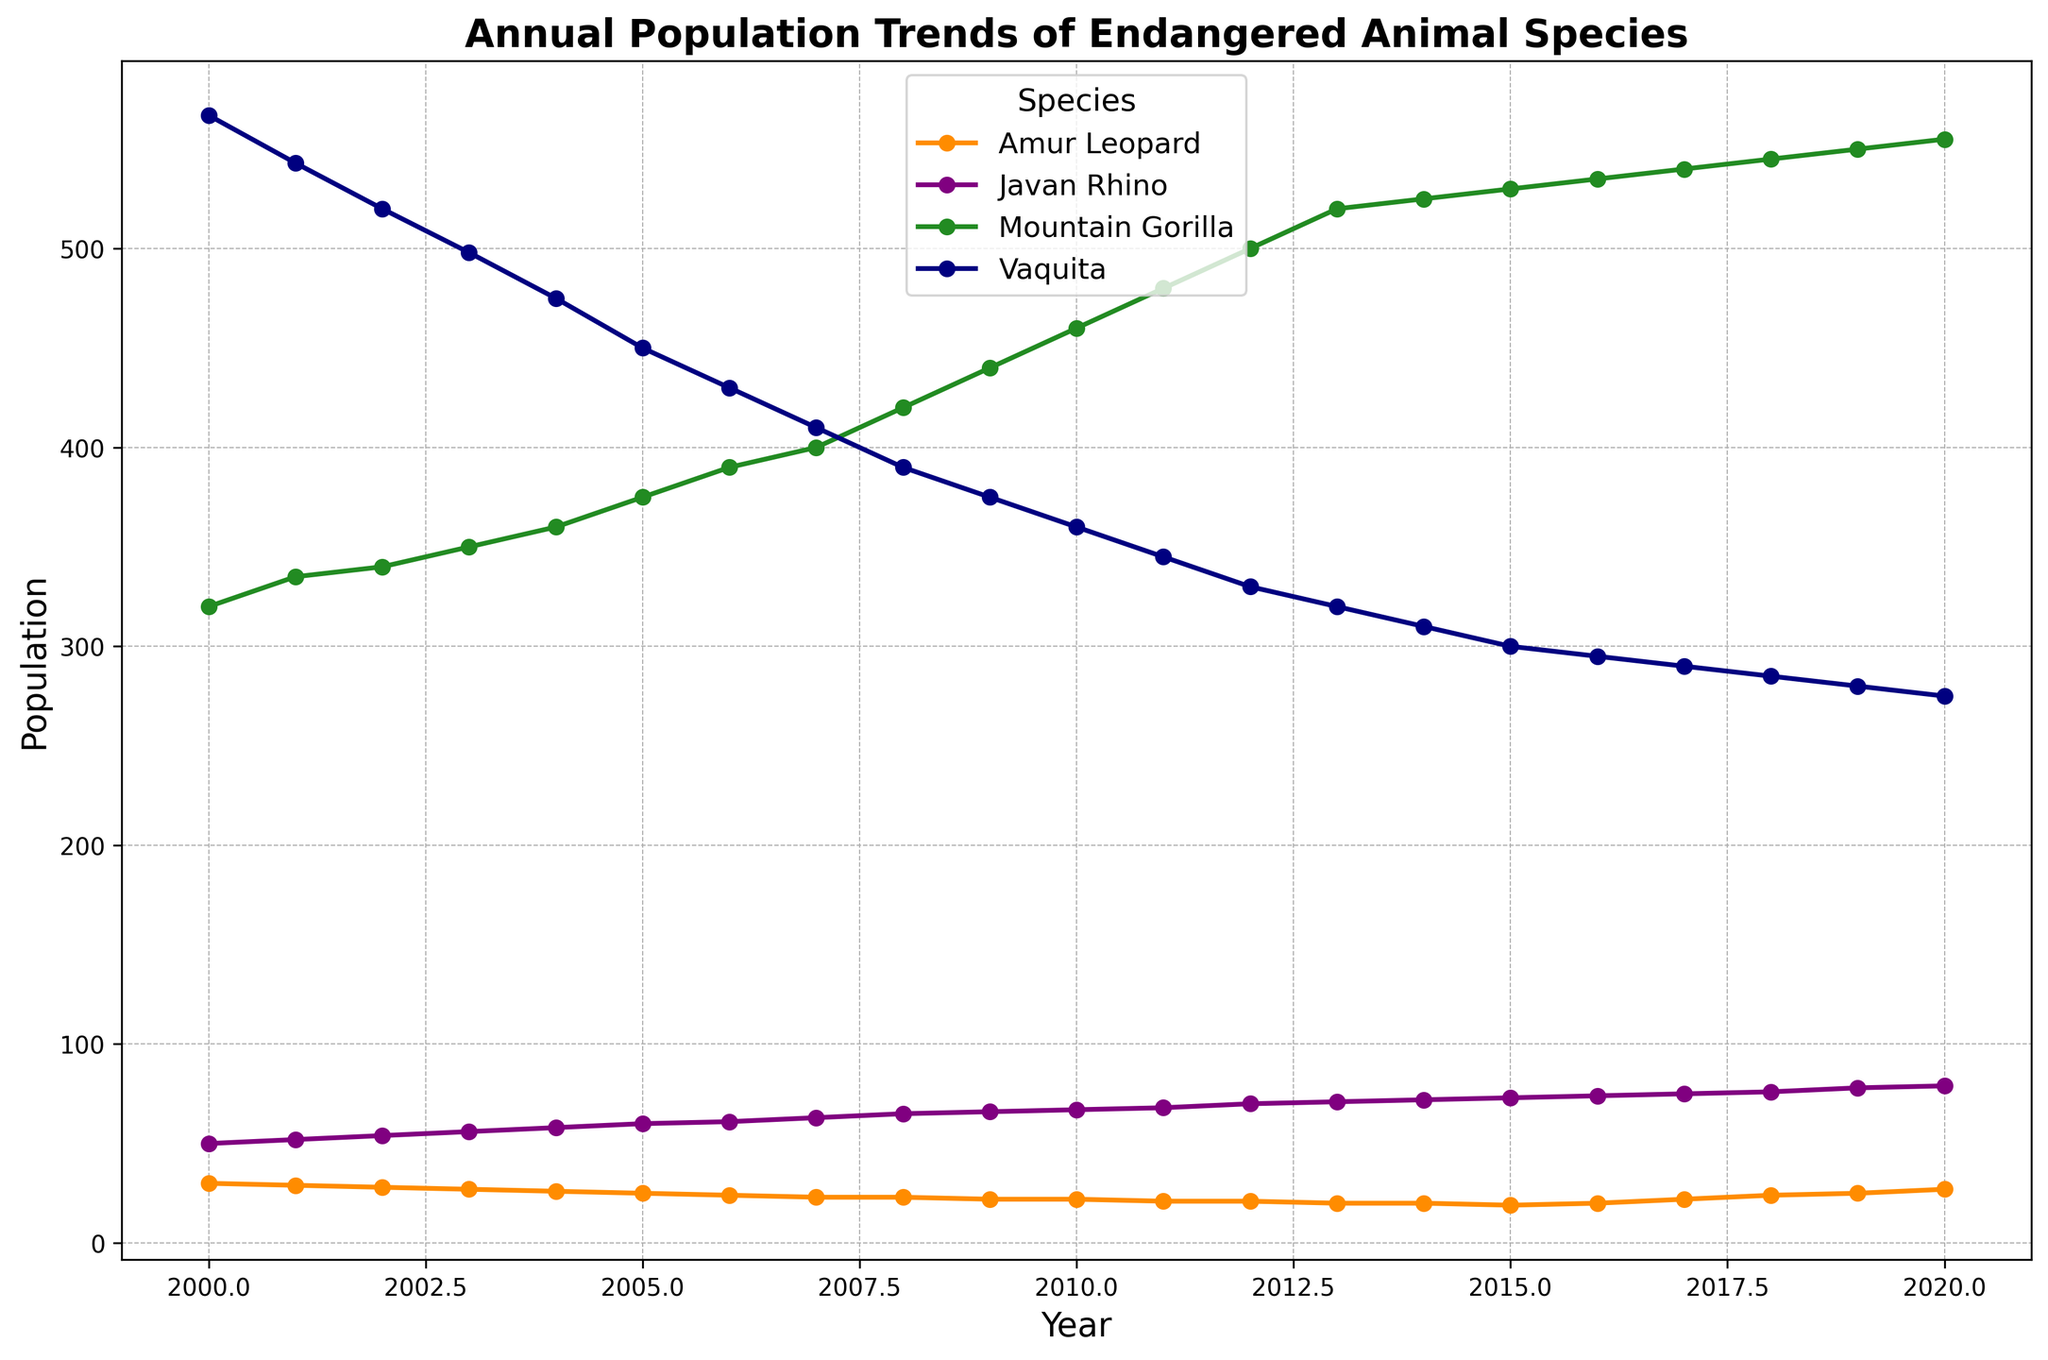What species had the lowest population in the year 2000? To find this, look at the population values for all species in the year 2000. The Amur Leopard had a population of 30, which is the lowest compared to the Javan Rhino (50), Mountain Gorilla (320), and Vaquita (567).
Answer: Amur Leopard Which species experienced the most significant overall population increase from 2000 to 2020? Calculate the difference between the population in 2020 and 2000 for each species. Amur Leopard: 27 - 30 = -3; Javan Rhino: 79 - 50 = 29; Mountain Gorilla: 555 - 320 = 235; Vaquita: 275 - 567 = -292. The Mountain Gorilla had the largest increase (235).
Answer: Mountain Gorilla Between 2015 and 2020, which species showed a trend of increasing population? Evaluate the population change from 2015 to 2020 for each species. Amur Leopard increased from 19 to 27, Javan Rhino increased from 73 to 79, Mountain Gorilla increased from 530 to 555, and Vaquita decreased from 300 to 275. Amur Leopard, Javan Rhino, and Mountain Gorilla all showed an increasing trend.
Answer: Amur Leopard, Javan Rhino, Mountain Gorilla How many species ended with a higher population in 2020 than they started with in 2000? Compare the population of each species in 2020 to their population in 2000. Amur Leopard: 27 vs. 30 (lower), Javan Rhino: 79 vs. 50 (higher), Mountain Gorilla: 555 vs. 320 (higher), Vaquita: 275 vs. 567 (lower). Two species (Javan Rhino and Mountain Gorilla) have higher populations in 2020.
Answer: Two What is the total population of all species combined in the year 2010? Sum the populations of all species in 2010: Amur Leopard (22), Javan Rhino (67), Mountain Gorilla (460), and Vaquita (360). 22 + 67 + 460 + 360 = 909.
Answer: 909 Which species had the most consistent population decline from 2000 to 2020? Calculate the changes in population year by year and look for consistent decline. The Vaquita’s population decreases almost every year from 567 in 2000 to 275 in 2020, making it the species with the most consistent decline.
Answer: Vaquita What is the average population of the Mountain Gorilla across all the years presented? Sum the Mountain Gorilla populations from 2000 to 2020, then divide by the number of years (21). (320+335+340+350+360+375+390+400+420+440+460+480+500+520+525+530+535+540+545+550+555) / 21 = 431.4.
Answer: 431.4 Between the Amur Leopard and the Vaquita, which species had a lower population in 2015? Compare the populations of these two species in 2015. Amur Leopard had 19 and Vaquita had 300. The Amur Leopard had a lower population in 2015.
Answer: Amur Leopard What species’ population increased to its highest value in the year 2020? Look for the population values of all species in 2020 and identify the highest. Mountain Gorilla reached 555, which is its highest recorded population.
Answer: Mountain Gorilla By what percentage did the Vaquita population decrease from the year 2000 to the year 2020? Calculate the decrease from 2000 to 2020 (567 to 275). The decrease amount is 567 - 275 = 292. To find the percentage decrease: (292 / 567) * 100 ≈ 51.5%.
Answer: 51.5% 